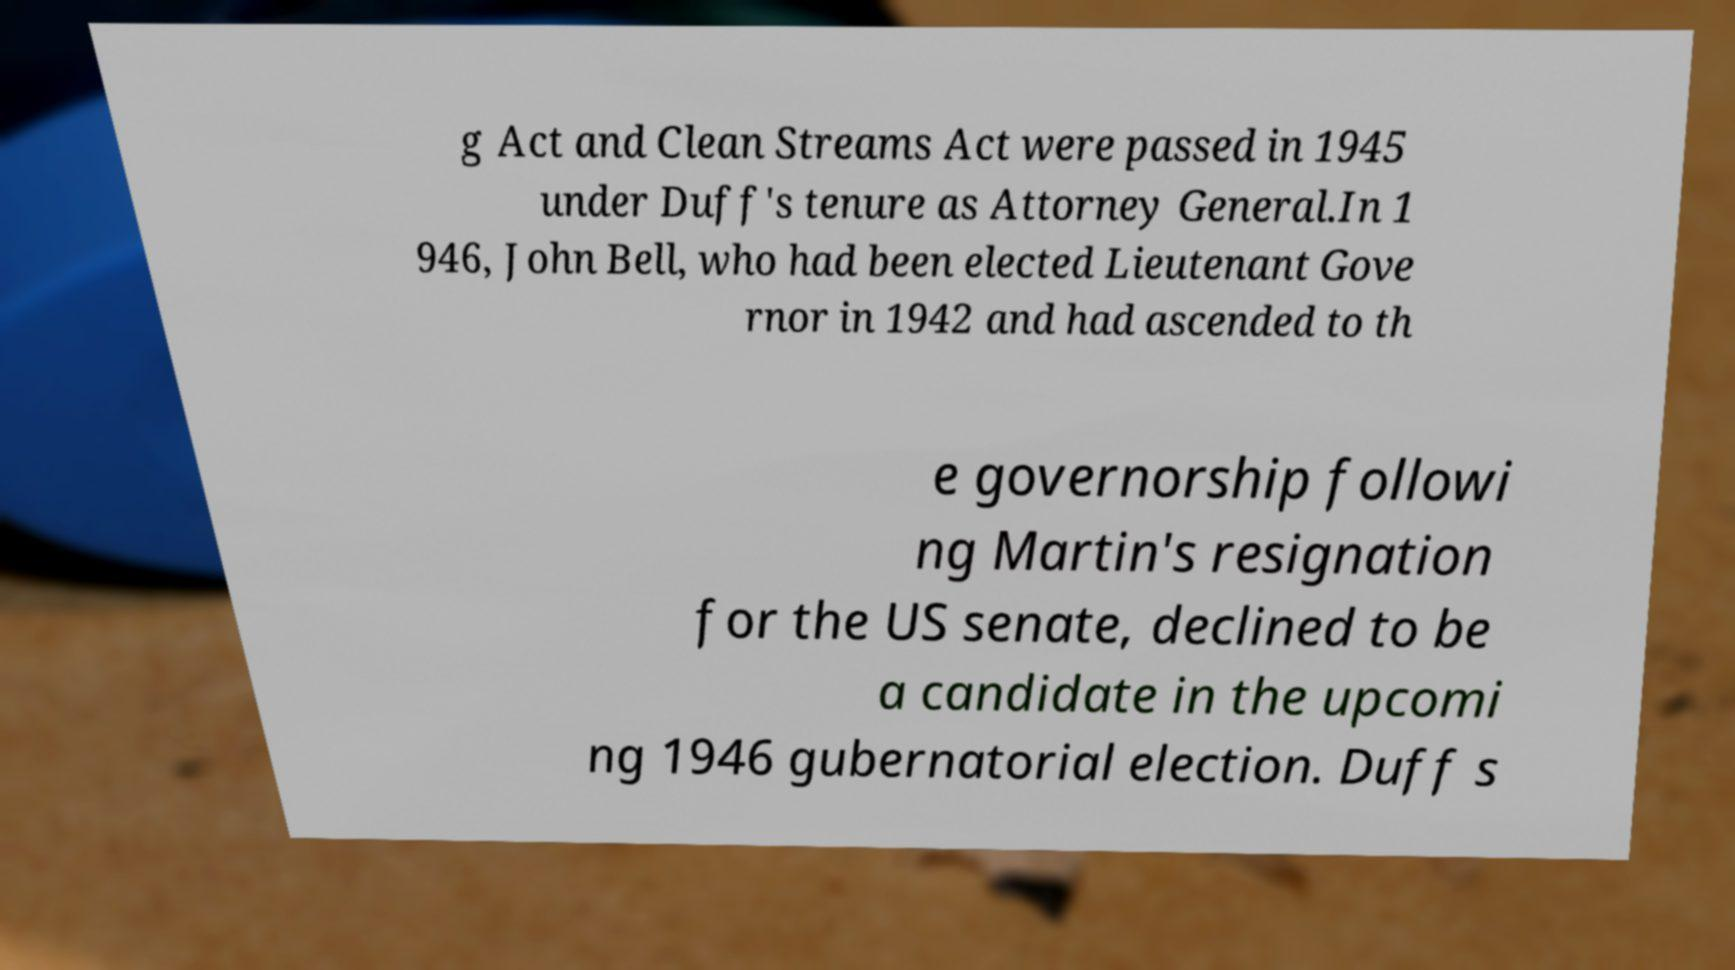For documentation purposes, I need the text within this image transcribed. Could you provide that? g Act and Clean Streams Act were passed in 1945 under Duff's tenure as Attorney General.In 1 946, John Bell, who had been elected Lieutenant Gove rnor in 1942 and had ascended to th e governorship followi ng Martin's resignation for the US senate, declined to be a candidate in the upcomi ng 1946 gubernatorial election. Duff s 